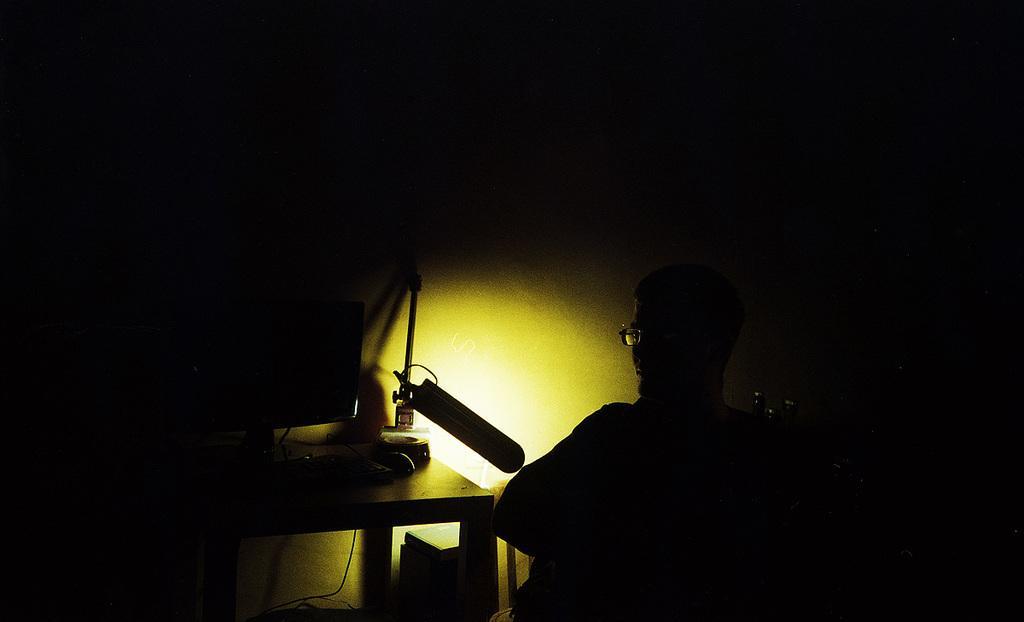Could you give a brief overview of what you see in this image? This is a dark image. In this image we can see a person wearing specs. Also there is a table. On the table there is a computer and some other items. Also there is light. 